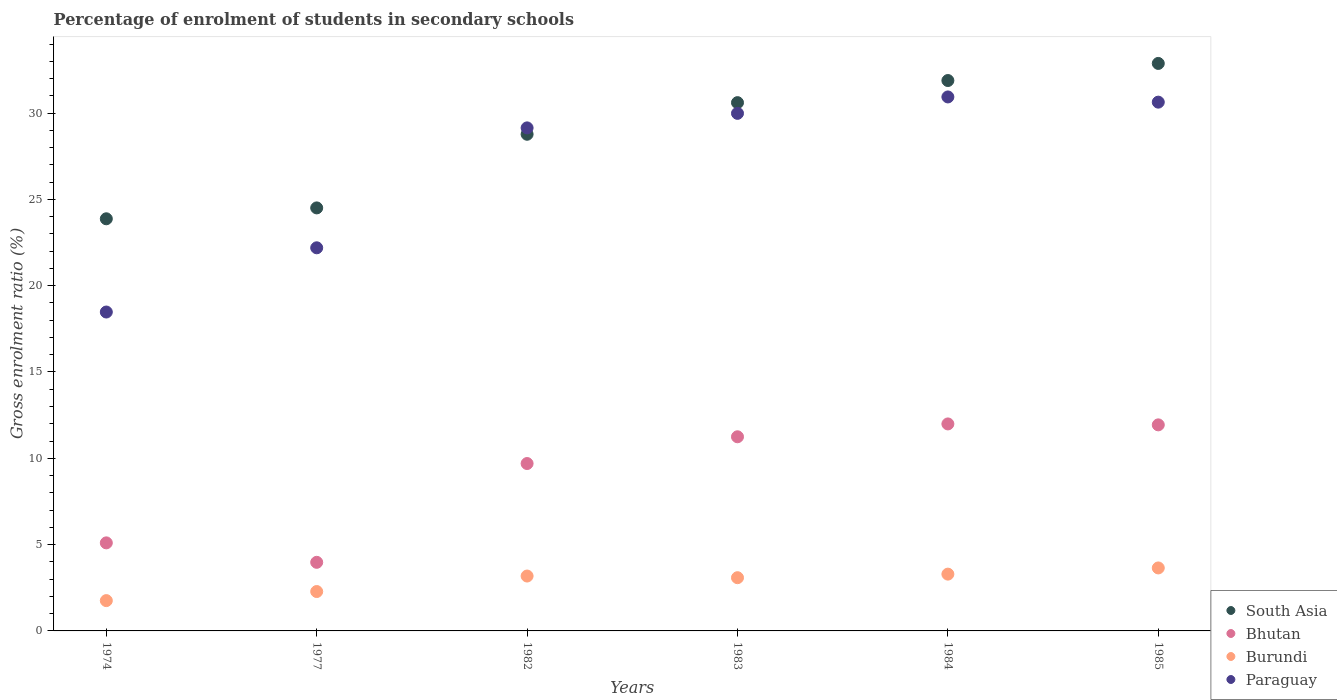What is the percentage of students enrolled in secondary schools in Bhutan in 1983?
Ensure brevity in your answer.  11.25. Across all years, what is the maximum percentage of students enrolled in secondary schools in Burundi?
Give a very brief answer. 3.65. Across all years, what is the minimum percentage of students enrolled in secondary schools in Paraguay?
Keep it short and to the point. 18.47. In which year was the percentage of students enrolled in secondary schools in Paraguay maximum?
Provide a short and direct response. 1984. In which year was the percentage of students enrolled in secondary schools in South Asia minimum?
Provide a short and direct response. 1974. What is the total percentage of students enrolled in secondary schools in Paraguay in the graph?
Ensure brevity in your answer.  161.36. What is the difference between the percentage of students enrolled in secondary schools in Paraguay in 1974 and that in 1984?
Ensure brevity in your answer.  -12.46. What is the difference between the percentage of students enrolled in secondary schools in Bhutan in 1984 and the percentage of students enrolled in secondary schools in South Asia in 1985?
Your response must be concise. -20.88. What is the average percentage of students enrolled in secondary schools in Bhutan per year?
Your answer should be compact. 8.99. In the year 1984, what is the difference between the percentage of students enrolled in secondary schools in Paraguay and percentage of students enrolled in secondary schools in Burundi?
Offer a terse response. 27.64. What is the ratio of the percentage of students enrolled in secondary schools in South Asia in 1977 to that in 1984?
Offer a very short reply. 0.77. Is the difference between the percentage of students enrolled in secondary schools in Paraguay in 1974 and 1985 greater than the difference between the percentage of students enrolled in secondary schools in Burundi in 1974 and 1985?
Ensure brevity in your answer.  No. What is the difference between the highest and the second highest percentage of students enrolled in secondary schools in Paraguay?
Your answer should be very brief. 0.3. What is the difference between the highest and the lowest percentage of students enrolled in secondary schools in Paraguay?
Offer a terse response. 12.46. In how many years, is the percentage of students enrolled in secondary schools in Paraguay greater than the average percentage of students enrolled in secondary schools in Paraguay taken over all years?
Offer a terse response. 4. Is it the case that in every year, the sum of the percentage of students enrolled in secondary schools in Bhutan and percentage of students enrolled in secondary schools in South Asia  is greater than the sum of percentage of students enrolled in secondary schools in Burundi and percentage of students enrolled in secondary schools in Paraguay?
Ensure brevity in your answer.  Yes. Does the percentage of students enrolled in secondary schools in Bhutan monotonically increase over the years?
Your answer should be very brief. No. Is the percentage of students enrolled in secondary schools in Burundi strictly greater than the percentage of students enrolled in secondary schools in Bhutan over the years?
Keep it short and to the point. No. Is the percentage of students enrolled in secondary schools in South Asia strictly less than the percentage of students enrolled in secondary schools in Bhutan over the years?
Provide a succinct answer. No. How many years are there in the graph?
Ensure brevity in your answer.  6. Does the graph contain grids?
Make the answer very short. No. Where does the legend appear in the graph?
Offer a terse response. Bottom right. What is the title of the graph?
Give a very brief answer. Percentage of enrolment of students in secondary schools. Does "Sao Tome and Principe" appear as one of the legend labels in the graph?
Provide a short and direct response. No. What is the label or title of the X-axis?
Keep it short and to the point. Years. What is the label or title of the Y-axis?
Give a very brief answer. Gross enrolment ratio (%). What is the Gross enrolment ratio (%) in South Asia in 1974?
Ensure brevity in your answer.  23.87. What is the Gross enrolment ratio (%) in Bhutan in 1974?
Keep it short and to the point. 5.1. What is the Gross enrolment ratio (%) in Burundi in 1974?
Your answer should be compact. 1.76. What is the Gross enrolment ratio (%) of Paraguay in 1974?
Keep it short and to the point. 18.47. What is the Gross enrolment ratio (%) of South Asia in 1977?
Provide a succinct answer. 24.51. What is the Gross enrolment ratio (%) of Bhutan in 1977?
Make the answer very short. 3.97. What is the Gross enrolment ratio (%) of Burundi in 1977?
Provide a succinct answer. 2.28. What is the Gross enrolment ratio (%) in Paraguay in 1977?
Provide a succinct answer. 22.19. What is the Gross enrolment ratio (%) of South Asia in 1982?
Offer a very short reply. 28.77. What is the Gross enrolment ratio (%) of Bhutan in 1982?
Keep it short and to the point. 9.7. What is the Gross enrolment ratio (%) of Burundi in 1982?
Offer a terse response. 3.18. What is the Gross enrolment ratio (%) of Paraguay in 1982?
Offer a terse response. 29.14. What is the Gross enrolment ratio (%) in South Asia in 1983?
Ensure brevity in your answer.  30.6. What is the Gross enrolment ratio (%) of Bhutan in 1983?
Offer a terse response. 11.25. What is the Gross enrolment ratio (%) of Burundi in 1983?
Provide a succinct answer. 3.08. What is the Gross enrolment ratio (%) in Paraguay in 1983?
Give a very brief answer. 29.98. What is the Gross enrolment ratio (%) of South Asia in 1984?
Your answer should be very brief. 31.88. What is the Gross enrolment ratio (%) in Bhutan in 1984?
Make the answer very short. 11.99. What is the Gross enrolment ratio (%) in Burundi in 1984?
Ensure brevity in your answer.  3.29. What is the Gross enrolment ratio (%) of Paraguay in 1984?
Offer a terse response. 30.93. What is the Gross enrolment ratio (%) of South Asia in 1985?
Offer a terse response. 32.87. What is the Gross enrolment ratio (%) in Bhutan in 1985?
Your answer should be compact. 11.94. What is the Gross enrolment ratio (%) in Burundi in 1985?
Give a very brief answer. 3.65. What is the Gross enrolment ratio (%) of Paraguay in 1985?
Offer a terse response. 30.63. Across all years, what is the maximum Gross enrolment ratio (%) of South Asia?
Offer a terse response. 32.87. Across all years, what is the maximum Gross enrolment ratio (%) in Bhutan?
Make the answer very short. 11.99. Across all years, what is the maximum Gross enrolment ratio (%) of Burundi?
Make the answer very short. 3.65. Across all years, what is the maximum Gross enrolment ratio (%) of Paraguay?
Offer a terse response. 30.93. Across all years, what is the minimum Gross enrolment ratio (%) of South Asia?
Your response must be concise. 23.87. Across all years, what is the minimum Gross enrolment ratio (%) of Bhutan?
Offer a terse response. 3.97. Across all years, what is the minimum Gross enrolment ratio (%) of Burundi?
Provide a succinct answer. 1.76. Across all years, what is the minimum Gross enrolment ratio (%) in Paraguay?
Make the answer very short. 18.47. What is the total Gross enrolment ratio (%) in South Asia in the graph?
Offer a very short reply. 172.51. What is the total Gross enrolment ratio (%) of Bhutan in the graph?
Ensure brevity in your answer.  53.95. What is the total Gross enrolment ratio (%) of Burundi in the graph?
Your response must be concise. 17.24. What is the total Gross enrolment ratio (%) in Paraguay in the graph?
Your response must be concise. 161.36. What is the difference between the Gross enrolment ratio (%) of South Asia in 1974 and that in 1977?
Your answer should be very brief. -0.63. What is the difference between the Gross enrolment ratio (%) of Bhutan in 1974 and that in 1977?
Provide a short and direct response. 1.13. What is the difference between the Gross enrolment ratio (%) of Burundi in 1974 and that in 1977?
Your response must be concise. -0.53. What is the difference between the Gross enrolment ratio (%) of Paraguay in 1974 and that in 1977?
Provide a short and direct response. -3.72. What is the difference between the Gross enrolment ratio (%) of South Asia in 1974 and that in 1982?
Provide a short and direct response. -4.9. What is the difference between the Gross enrolment ratio (%) of Bhutan in 1974 and that in 1982?
Your answer should be compact. -4.6. What is the difference between the Gross enrolment ratio (%) in Burundi in 1974 and that in 1982?
Your answer should be compact. -1.42. What is the difference between the Gross enrolment ratio (%) of Paraguay in 1974 and that in 1982?
Provide a short and direct response. -10.67. What is the difference between the Gross enrolment ratio (%) of South Asia in 1974 and that in 1983?
Provide a succinct answer. -6.73. What is the difference between the Gross enrolment ratio (%) in Bhutan in 1974 and that in 1983?
Ensure brevity in your answer.  -6.15. What is the difference between the Gross enrolment ratio (%) in Burundi in 1974 and that in 1983?
Your response must be concise. -1.33. What is the difference between the Gross enrolment ratio (%) of Paraguay in 1974 and that in 1983?
Offer a terse response. -11.51. What is the difference between the Gross enrolment ratio (%) in South Asia in 1974 and that in 1984?
Offer a terse response. -8.01. What is the difference between the Gross enrolment ratio (%) in Bhutan in 1974 and that in 1984?
Your answer should be compact. -6.89. What is the difference between the Gross enrolment ratio (%) in Burundi in 1974 and that in 1984?
Provide a short and direct response. -1.53. What is the difference between the Gross enrolment ratio (%) of Paraguay in 1974 and that in 1984?
Your response must be concise. -12.46. What is the difference between the Gross enrolment ratio (%) of South Asia in 1974 and that in 1985?
Offer a very short reply. -9. What is the difference between the Gross enrolment ratio (%) in Bhutan in 1974 and that in 1985?
Your answer should be very brief. -6.84. What is the difference between the Gross enrolment ratio (%) in Burundi in 1974 and that in 1985?
Your answer should be very brief. -1.89. What is the difference between the Gross enrolment ratio (%) of Paraguay in 1974 and that in 1985?
Offer a terse response. -12.16. What is the difference between the Gross enrolment ratio (%) in South Asia in 1977 and that in 1982?
Offer a terse response. -4.27. What is the difference between the Gross enrolment ratio (%) in Bhutan in 1977 and that in 1982?
Keep it short and to the point. -5.72. What is the difference between the Gross enrolment ratio (%) of Burundi in 1977 and that in 1982?
Your response must be concise. -0.9. What is the difference between the Gross enrolment ratio (%) of Paraguay in 1977 and that in 1982?
Ensure brevity in your answer.  -6.95. What is the difference between the Gross enrolment ratio (%) of South Asia in 1977 and that in 1983?
Offer a terse response. -6.1. What is the difference between the Gross enrolment ratio (%) of Bhutan in 1977 and that in 1983?
Ensure brevity in your answer.  -7.27. What is the difference between the Gross enrolment ratio (%) in Burundi in 1977 and that in 1983?
Your answer should be very brief. -0.8. What is the difference between the Gross enrolment ratio (%) of Paraguay in 1977 and that in 1983?
Give a very brief answer. -7.79. What is the difference between the Gross enrolment ratio (%) in South Asia in 1977 and that in 1984?
Make the answer very short. -7.38. What is the difference between the Gross enrolment ratio (%) of Bhutan in 1977 and that in 1984?
Offer a very short reply. -8.02. What is the difference between the Gross enrolment ratio (%) of Burundi in 1977 and that in 1984?
Provide a succinct answer. -1.01. What is the difference between the Gross enrolment ratio (%) of Paraguay in 1977 and that in 1984?
Keep it short and to the point. -8.74. What is the difference between the Gross enrolment ratio (%) of South Asia in 1977 and that in 1985?
Keep it short and to the point. -8.37. What is the difference between the Gross enrolment ratio (%) in Bhutan in 1977 and that in 1985?
Make the answer very short. -7.96. What is the difference between the Gross enrolment ratio (%) of Burundi in 1977 and that in 1985?
Your answer should be very brief. -1.37. What is the difference between the Gross enrolment ratio (%) in Paraguay in 1977 and that in 1985?
Provide a short and direct response. -8.44. What is the difference between the Gross enrolment ratio (%) of South Asia in 1982 and that in 1983?
Your answer should be very brief. -1.83. What is the difference between the Gross enrolment ratio (%) of Bhutan in 1982 and that in 1983?
Your response must be concise. -1.55. What is the difference between the Gross enrolment ratio (%) of Burundi in 1982 and that in 1983?
Give a very brief answer. 0.1. What is the difference between the Gross enrolment ratio (%) in Paraguay in 1982 and that in 1983?
Offer a very short reply. -0.84. What is the difference between the Gross enrolment ratio (%) in South Asia in 1982 and that in 1984?
Offer a terse response. -3.11. What is the difference between the Gross enrolment ratio (%) in Bhutan in 1982 and that in 1984?
Offer a terse response. -2.29. What is the difference between the Gross enrolment ratio (%) of Burundi in 1982 and that in 1984?
Your answer should be very brief. -0.11. What is the difference between the Gross enrolment ratio (%) in Paraguay in 1982 and that in 1984?
Offer a terse response. -1.79. What is the difference between the Gross enrolment ratio (%) in South Asia in 1982 and that in 1985?
Give a very brief answer. -4.1. What is the difference between the Gross enrolment ratio (%) of Bhutan in 1982 and that in 1985?
Keep it short and to the point. -2.24. What is the difference between the Gross enrolment ratio (%) of Burundi in 1982 and that in 1985?
Provide a succinct answer. -0.47. What is the difference between the Gross enrolment ratio (%) of Paraguay in 1982 and that in 1985?
Your answer should be compact. -1.49. What is the difference between the Gross enrolment ratio (%) of South Asia in 1983 and that in 1984?
Keep it short and to the point. -1.28. What is the difference between the Gross enrolment ratio (%) of Bhutan in 1983 and that in 1984?
Give a very brief answer. -0.74. What is the difference between the Gross enrolment ratio (%) in Burundi in 1983 and that in 1984?
Your answer should be compact. -0.21. What is the difference between the Gross enrolment ratio (%) of Paraguay in 1983 and that in 1984?
Keep it short and to the point. -0.95. What is the difference between the Gross enrolment ratio (%) in South Asia in 1983 and that in 1985?
Your response must be concise. -2.27. What is the difference between the Gross enrolment ratio (%) of Bhutan in 1983 and that in 1985?
Your response must be concise. -0.69. What is the difference between the Gross enrolment ratio (%) in Burundi in 1983 and that in 1985?
Your answer should be very brief. -0.57. What is the difference between the Gross enrolment ratio (%) of Paraguay in 1983 and that in 1985?
Offer a very short reply. -0.65. What is the difference between the Gross enrolment ratio (%) in South Asia in 1984 and that in 1985?
Ensure brevity in your answer.  -0.99. What is the difference between the Gross enrolment ratio (%) of Bhutan in 1984 and that in 1985?
Ensure brevity in your answer.  0.05. What is the difference between the Gross enrolment ratio (%) of Burundi in 1984 and that in 1985?
Your response must be concise. -0.36. What is the difference between the Gross enrolment ratio (%) in Paraguay in 1984 and that in 1985?
Provide a succinct answer. 0.3. What is the difference between the Gross enrolment ratio (%) of South Asia in 1974 and the Gross enrolment ratio (%) of Bhutan in 1977?
Ensure brevity in your answer.  19.9. What is the difference between the Gross enrolment ratio (%) in South Asia in 1974 and the Gross enrolment ratio (%) in Burundi in 1977?
Your answer should be compact. 21.59. What is the difference between the Gross enrolment ratio (%) of South Asia in 1974 and the Gross enrolment ratio (%) of Paraguay in 1977?
Offer a very short reply. 1.68. What is the difference between the Gross enrolment ratio (%) in Bhutan in 1974 and the Gross enrolment ratio (%) in Burundi in 1977?
Keep it short and to the point. 2.82. What is the difference between the Gross enrolment ratio (%) of Bhutan in 1974 and the Gross enrolment ratio (%) of Paraguay in 1977?
Offer a very short reply. -17.09. What is the difference between the Gross enrolment ratio (%) in Burundi in 1974 and the Gross enrolment ratio (%) in Paraguay in 1977?
Offer a terse response. -20.44. What is the difference between the Gross enrolment ratio (%) of South Asia in 1974 and the Gross enrolment ratio (%) of Bhutan in 1982?
Offer a terse response. 14.18. What is the difference between the Gross enrolment ratio (%) in South Asia in 1974 and the Gross enrolment ratio (%) in Burundi in 1982?
Ensure brevity in your answer.  20.7. What is the difference between the Gross enrolment ratio (%) of South Asia in 1974 and the Gross enrolment ratio (%) of Paraguay in 1982?
Your response must be concise. -5.27. What is the difference between the Gross enrolment ratio (%) of Bhutan in 1974 and the Gross enrolment ratio (%) of Burundi in 1982?
Provide a succinct answer. 1.92. What is the difference between the Gross enrolment ratio (%) in Bhutan in 1974 and the Gross enrolment ratio (%) in Paraguay in 1982?
Offer a terse response. -24.04. What is the difference between the Gross enrolment ratio (%) in Burundi in 1974 and the Gross enrolment ratio (%) in Paraguay in 1982?
Ensure brevity in your answer.  -27.38. What is the difference between the Gross enrolment ratio (%) in South Asia in 1974 and the Gross enrolment ratio (%) in Bhutan in 1983?
Your response must be concise. 12.63. What is the difference between the Gross enrolment ratio (%) of South Asia in 1974 and the Gross enrolment ratio (%) of Burundi in 1983?
Your response must be concise. 20.79. What is the difference between the Gross enrolment ratio (%) in South Asia in 1974 and the Gross enrolment ratio (%) in Paraguay in 1983?
Your response must be concise. -6.11. What is the difference between the Gross enrolment ratio (%) of Bhutan in 1974 and the Gross enrolment ratio (%) of Burundi in 1983?
Offer a very short reply. 2.02. What is the difference between the Gross enrolment ratio (%) in Bhutan in 1974 and the Gross enrolment ratio (%) in Paraguay in 1983?
Your answer should be very brief. -24.88. What is the difference between the Gross enrolment ratio (%) of Burundi in 1974 and the Gross enrolment ratio (%) of Paraguay in 1983?
Provide a short and direct response. -28.23. What is the difference between the Gross enrolment ratio (%) of South Asia in 1974 and the Gross enrolment ratio (%) of Bhutan in 1984?
Your answer should be compact. 11.88. What is the difference between the Gross enrolment ratio (%) in South Asia in 1974 and the Gross enrolment ratio (%) in Burundi in 1984?
Offer a very short reply. 20.58. What is the difference between the Gross enrolment ratio (%) of South Asia in 1974 and the Gross enrolment ratio (%) of Paraguay in 1984?
Offer a very short reply. -7.06. What is the difference between the Gross enrolment ratio (%) in Bhutan in 1974 and the Gross enrolment ratio (%) in Burundi in 1984?
Ensure brevity in your answer.  1.81. What is the difference between the Gross enrolment ratio (%) of Bhutan in 1974 and the Gross enrolment ratio (%) of Paraguay in 1984?
Give a very brief answer. -25.83. What is the difference between the Gross enrolment ratio (%) in Burundi in 1974 and the Gross enrolment ratio (%) in Paraguay in 1984?
Offer a terse response. -29.18. What is the difference between the Gross enrolment ratio (%) of South Asia in 1974 and the Gross enrolment ratio (%) of Bhutan in 1985?
Offer a very short reply. 11.94. What is the difference between the Gross enrolment ratio (%) of South Asia in 1974 and the Gross enrolment ratio (%) of Burundi in 1985?
Ensure brevity in your answer.  20.23. What is the difference between the Gross enrolment ratio (%) in South Asia in 1974 and the Gross enrolment ratio (%) in Paraguay in 1985?
Provide a short and direct response. -6.76. What is the difference between the Gross enrolment ratio (%) in Bhutan in 1974 and the Gross enrolment ratio (%) in Burundi in 1985?
Give a very brief answer. 1.45. What is the difference between the Gross enrolment ratio (%) of Bhutan in 1974 and the Gross enrolment ratio (%) of Paraguay in 1985?
Provide a succinct answer. -25.53. What is the difference between the Gross enrolment ratio (%) of Burundi in 1974 and the Gross enrolment ratio (%) of Paraguay in 1985?
Provide a short and direct response. -28.88. What is the difference between the Gross enrolment ratio (%) in South Asia in 1977 and the Gross enrolment ratio (%) in Bhutan in 1982?
Keep it short and to the point. 14.81. What is the difference between the Gross enrolment ratio (%) of South Asia in 1977 and the Gross enrolment ratio (%) of Burundi in 1982?
Ensure brevity in your answer.  21.33. What is the difference between the Gross enrolment ratio (%) of South Asia in 1977 and the Gross enrolment ratio (%) of Paraguay in 1982?
Ensure brevity in your answer.  -4.64. What is the difference between the Gross enrolment ratio (%) of Bhutan in 1977 and the Gross enrolment ratio (%) of Burundi in 1982?
Make the answer very short. 0.79. What is the difference between the Gross enrolment ratio (%) of Bhutan in 1977 and the Gross enrolment ratio (%) of Paraguay in 1982?
Make the answer very short. -25.17. What is the difference between the Gross enrolment ratio (%) of Burundi in 1977 and the Gross enrolment ratio (%) of Paraguay in 1982?
Your answer should be very brief. -26.86. What is the difference between the Gross enrolment ratio (%) of South Asia in 1977 and the Gross enrolment ratio (%) of Bhutan in 1983?
Offer a terse response. 13.26. What is the difference between the Gross enrolment ratio (%) of South Asia in 1977 and the Gross enrolment ratio (%) of Burundi in 1983?
Ensure brevity in your answer.  21.42. What is the difference between the Gross enrolment ratio (%) in South Asia in 1977 and the Gross enrolment ratio (%) in Paraguay in 1983?
Provide a succinct answer. -5.48. What is the difference between the Gross enrolment ratio (%) of Bhutan in 1977 and the Gross enrolment ratio (%) of Burundi in 1983?
Provide a short and direct response. 0.89. What is the difference between the Gross enrolment ratio (%) of Bhutan in 1977 and the Gross enrolment ratio (%) of Paraguay in 1983?
Provide a succinct answer. -26.01. What is the difference between the Gross enrolment ratio (%) in Burundi in 1977 and the Gross enrolment ratio (%) in Paraguay in 1983?
Ensure brevity in your answer.  -27.7. What is the difference between the Gross enrolment ratio (%) of South Asia in 1977 and the Gross enrolment ratio (%) of Bhutan in 1984?
Keep it short and to the point. 12.51. What is the difference between the Gross enrolment ratio (%) of South Asia in 1977 and the Gross enrolment ratio (%) of Burundi in 1984?
Provide a short and direct response. 21.22. What is the difference between the Gross enrolment ratio (%) in South Asia in 1977 and the Gross enrolment ratio (%) in Paraguay in 1984?
Provide a succinct answer. -6.43. What is the difference between the Gross enrolment ratio (%) of Bhutan in 1977 and the Gross enrolment ratio (%) of Burundi in 1984?
Your answer should be compact. 0.68. What is the difference between the Gross enrolment ratio (%) of Bhutan in 1977 and the Gross enrolment ratio (%) of Paraguay in 1984?
Your response must be concise. -26.96. What is the difference between the Gross enrolment ratio (%) of Burundi in 1977 and the Gross enrolment ratio (%) of Paraguay in 1984?
Offer a terse response. -28.65. What is the difference between the Gross enrolment ratio (%) in South Asia in 1977 and the Gross enrolment ratio (%) in Bhutan in 1985?
Your response must be concise. 12.57. What is the difference between the Gross enrolment ratio (%) in South Asia in 1977 and the Gross enrolment ratio (%) in Burundi in 1985?
Make the answer very short. 20.86. What is the difference between the Gross enrolment ratio (%) of South Asia in 1977 and the Gross enrolment ratio (%) of Paraguay in 1985?
Make the answer very short. -6.13. What is the difference between the Gross enrolment ratio (%) in Bhutan in 1977 and the Gross enrolment ratio (%) in Burundi in 1985?
Provide a short and direct response. 0.33. What is the difference between the Gross enrolment ratio (%) in Bhutan in 1977 and the Gross enrolment ratio (%) in Paraguay in 1985?
Give a very brief answer. -26.66. What is the difference between the Gross enrolment ratio (%) in Burundi in 1977 and the Gross enrolment ratio (%) in Paraguay in 1985?
Ensure brevity in your answer.  -28.35. What is the difference between the Gross enrolment ratio (%) of South Asia in 1982 and the Gross enrolment ratio (%) of Bhutan in 1983?
Give a very brief answer. 17.53. What is the difference between the Gross enrolment ratio (%) in South Asia in 1982 and the Gross enrolment ratio (%) in Burundi in 1983?
Offer a terse response. 25.69. What is the difference between the Gross enrolment ratio (%) in South Asia in 1982 and the Gross enrolment ratio (%) in Paraguay in 1983?
Keep it short and to the point. -1.21. What is the difference between the Gross enrolment ratio (%) of Bhutan in 1982 and the Gross enrolment ratio (%) of Burundi in 1983?
Your answer should be very brief. 6.61. What is the difference between the Gross enrolment ratio (%) in Bhutan in 1982 and the Gross enrolment ratio (%) in Paraguay in 1983?
Provide a succinct answer. -20.29. What is the difference between the Gross enrolment ratio (%) of Burundi in 1982 and the Gross enrolment ratio (%) of Paraguay in 1983?
Keep it short and to the point. -26.8. What is the difference between the Gross enrolment ratio (%) in South Asia in 1982 and the Gross enrolment ratio (%) in Bhutan in 1984?
Give a very brief answer. 16.78. What is the difference between the Gross enrolment ratio (%) in South Asia in 1982 and the Gross enrolment ratio (%) in Burundi in 1984?
Offer a very short reply. 25.48. What is the difference between the Gross enrolment ratio (%) in South Asia in 1982 and the Gross enrolment ratio (%) in Paraguay in 1984?
Keep it short and to the point. -2.16. What is the difference between the Gross enrolment ratio (%) of Bhutan in 1982 and the Gross enrolment ratio (%) of Burundi in 1984?
Provide a succinct answer. 6.41. What is the difference between the Gross enrolment ratio (%) of Bhutan in 1982 and the Gross enrolment ratio (%) of Paraguay in 1984?
Offer a terse response. -21.24. What is the difference between the Gross enrolment ratio (%) in Burundi in 1982 and the Gross enrolment ratio (%) in Paraguay in 1984?
Make the answer very short. -27.75. What is the difference between the Gross enrolment ratio (%) in South Asia in 1982 and the Gross enrolment ratio (%) in Bhutan in 1985?
Provide a short and direct response. 16.83. What is the difference between the Gross enrolment ratio (%) in South Asia in 1982 and the Gross enrolment ratio (%) in Burundi in 1985?
Your answer should be compact. 25.12. What is the difference between the Gross enrolment ratio (%) of South Asia in 1982 and the Gross enrolment ratio (%) of Paraguay in 1985?
Provide a short and direct response. -1.86. What is the difference between the Gross enrolment ratio (%) of Bhutan in 1982 and the Gross enrolment ratio (%) of Burundi in 1985?
Provide a short and direct response. 6.05. What is the difference between the Gross enrolment ratio (%) of Bhutan in 1982 and the Gross enrolment ratio (%) of Paraguay in 1985?
Provide a short and direct response. -20.93. What is the difference between the Gross enrolment ratio (%) in Burundi in 1982 and the Gross enrolment ratio (%) in Paraguay in 1985?
Your response must be concise. -27.45. What is the difference between the Gross enrolment ratio (%) of South Asia in 1983 and the Gross enrolment ratio (%) of Bhutan in 1984?
Ensure brevity in your answer.  18.61. What is the difference between the Gross enrolment ratio (%) of South Asia in 1983 and the Gross enrolment ratio (%) of Burundi in 1984?
Offer a terse response. 27.31. What is the difference between the Gross enrolment ratio (%) of South Asia in 1983 and the Gross enrolment ratio (%) of Paraguay in 1984?
Provide a short and direct response. -0.33. What is the difference between the Gross enrolment ratio (%) of Bhutan in 1983 and the Gross enrolment ratio (%) of Burundi in 1984?
Provide a succinct answer. 7.96. What is the difference between the Gross enrolment ratio (%) of Bhutan in 1983 and the Gross enrolment ratio (%) of Paraguay in 1984?
Provide a short and direct response. -19.69. What is the difference between the Gross enrolment ratio (%) in Burundi in 1983 and the Gross enrolment ratio (%) in Paraguay in 1984?
Your response must be concise. -27.85. What is the difference between the Gross enrolment ratio (%) in South Asia in 1983 and the Gross enrolment ratio (%) in Bhutan in 1985?
Give a very brief answer. 18.67. What is the difference between the Gross enrolment ratio (%) of South Asia in 1983 and the Gross enrolment ratio (%) of Burundi in 1985?
Provide a short and direct response. 26.95. What is the difference between the Gross enrolment ratio (%) of South Asia in 1983 and the Gross enrolment ratio (%) of Paraguay in 1985?
Your answer should be compact. -0.03. What is the difference between the Gross enrolment ratio (%) in Bhutan in 1983 and the Gross enrolment ratio (%) in Burundi in 1985?
Your answer should be compact. 7.6. What is the difference between the Gross enrolment ratio (%) in Bhutan in 1983 and the Gross enrolment ratio (%) in Paraguay in 1985?
Offer a terse response. -19.39. What is the difference between the Gross enrolment ratio (%) in Burundi in 1983 and the Gross enrolment ratio (%) in Paraguay in 1985?
Provide a succinct answer. -27.55. What is the difference between the Gross enrolment ratio (%) of South Asia in 1984 and the Gross enrolment ratio (%) of Bhutan in 1985?
Your answer should be very brief. 19.95. What is the difference between the Gross enrolment ratio (%) in South Asia in 1984 and the Gross enrolment ratio (%) in Burundi in 1985?
Your response must be concise. 28.24. What is the difference between the Gross enrolment ratio (%) in South Asia in 1984 and the Gross enrolment ratio (%) in Paraguay in 1985?
Give a very brief answer. 1.25. What is the difference between the Gross enrolment ratio (%) in Bhutan in 1984 and the Gross enrolment ratio (%) in Burundi in 1985?
Offer a terse response. 8.34. What is the difference between the Gross enrolment ratio (%) in Bhutan in 1984 and the Gross enrolment ratio (%) in Paraguay in 1985?
Your answer should be very brief. -18.64. What is the difference between the Gross enrolment ratio (%) of Burundi in 1984 and the Gross enrolment ratio (%) of Paraguay in 1985?
Your answer should be very brief. -27.34. What is the average Gross enrolment ratio (%) of South Asia per year?
Provide a short and direct response. 28.75. What is the average Gross enrolment ratio (%) of Bhutan per year?
Provide a short and direct response. 8.99. What is the average Gross enrolment ratio (%) in Burundi per year?
Provide a short and direct response. 2.87. What is the average Gross enrolment ratio (%) in Paraguay per year?
Make the answer very short. 26.89. In the year 1974, what is the difference between the Gross enrolment ratio (%) of South Asia and Gross enrolment ratio (%) of Bhutan?
Offer a very short reply. 18.77. In the year 1974, what is the difference between the Gross enrolment ratio (%) of South Asia and Gross enrolment ratio (%) of Burundi?
Your response must be concise. 22.12. In the year 1974, what is the difference between the Gross enrolment ratio (%) of South Asia and Gross enrolment ratio (%) of Paraguay?
Keep it short and to the point. 5.4. In the year 1974, what is the difference between the Gross enrolment ratio (%) of Bhutan and Gross enrolment ratio (%) of Burundi?
Give a very brief answer. 3.34. In the year 1974, what is the difference between the Gross enrolment ratio (%) of Bhutan and Gross enrolment ratio (%) of Paraguay?
Give a very brief answer. -13.37. In the year 1974, what is the difference between the Gross enrolment ratio (%) in Burundi and Gross enrolment ratio (%) in Paraguay?
Keep it short and to the point. -16.72. In the year 1977, what is the difference between the Gross enrolment ratio (%) of South Asia and Gross enrolment ratio (%) of Bhutan?
Provide a short and direct response. 20.53. In the year 1977, what is the difference between the Gross enrolment ratio (%) in South Asia and Gross enrolment ratio (%) in Burundi?
Your answer should be very brief. 22.22. In the year 1977, what is the difference between the Gross enrolment ratio (%) of South Asia and Gross enrolment ratio (%) of Paraguay?
Provide a succinct answer. 2.31. In the year 1977, what is the difference between the Gross enrolment ratio (%) of Bhutan and Gross enrolment ratio (%) of Burundi?
Give a very brief answer. 1.69. In the year 1977, what is the difference between the Gross enrolment ratio (%) of Bhutan and Gross enrolment ratio (%) of Paraguay?
Your response must be concise. -18.22. In the year 1977, what is the difference between the Gross enrolment ratio (%) of Burundi and Gross enrolment ratio (%) of Paraguay?
Provide a succinct answer. -19.91. In the year 1982, what is the difference between the Gross enrolment ratio (%) in South Asia and Gross enrolment ratio (%) in Bhutan?
Offer a terse response. 19.07. In the year 1982, what is the difference between the Gross enrolment ratio (%) in South Asia and Gross enrolment ratio (%) in Burundi?
Give a very brief answer. 25.59. In the year 1982, what is the difference between the Gross enrolment ratio (%) in South Asia and Gross enrolment ratio (%) in Paraguay?
Your response must be concise. -0.37. In the year 1982, what is the difference between the Gross enrolment ratio (%) in Bhutan and Gross enrolment ratio (%) in Burundi?
Your answer should be compact. 6.52. In the year 1982, what is the difference between the Gross enrolment ratio (%) of Bhutan and Gross enrolment ratio (%) of Paraguay?
Ensure brevity in your answer.  -19.44. In the year 1982, what is the difference between the Gross enrolment ratio (%) of Burundi and Gross enrolment ratio (%) of Paraguay?
Your answer should be compact. -25.96. In the year 1983, what is the difference between the Gross enrolment ratio (%) of South Asia and Gross enrolment ratio (%) of Bhutan?
Offer a very short reply. 19.36. In the year 1983, what is the difference between the Gross enrolment ratio (%) in South Asia and Gross enrolment ratio (%) in Burundi?
Provide a short and direct response. 27.52. In the year 1983, what is the difference between the Gross enrolment ratio (%) in South Asia and Gross enrolment ratio (%) in Paraguay?
Make the answer very short. 0.62. In the year 1983, what is the difference between the Gross enrolment ratio (%) in Bhutan and Gross enrolment ratio (%) in Burundi?
Keep it short and to the point. 8.16. In the year 1983, what is the difference between the Gross enrolment ratio (%) in Bhutan and Gross enrolment ratio (%) in Paraguay?
Your answer should be very brief. -18.74. In the year 1983, what is the difference between the Gross enrolment ratio (%) of Burundi and Gross enrolment ratio (%) of Paraguay?
Your response must be concise. -26.9. In the year 1984, what is the difference between the Gross enrolment ratio (%) of South Asia and Gross enrolment ratio (%) of Bhutan?
Provide a succinct answer. 19.89. In the year 1984, what is the difference between the Gross enrolment ratio (%) of South Asia and Gross enrolment ratio (%) of Burundi?
Make the answer very short. 28.59. In the year 1984, what is the difference between the Gross enrolment ratio (%) of South Asia and Gross enrolment ratio (%) of Paraguay?
Your response must be concise. 0.95. In the year 1984, what is the difference between the Gross enrolment ratio (%) of Bhutan and Gross enrolment ratio (%) of Burundi?
Your answer should be very brief. 8.7. In the year 1984, what is the difference between the Gross enrolment ratio (%) in Bhutan and Gross enrolment ratio (%) in Paraguay?
Provide a succinct answer. -18.94. In the year 1984, what is the difference between the Gross enrolment ratio (%) of Burundi and Gross enrolment ratio (%) of Paraguay?
Give a very brief answer. -27.64. In the year 1985, what is the difference between the Gross enrolment ratio (%) of South Asia and Gross enrolment ratio (%) of Bhutan?
Offer a very short reply. 20.94. In the year 1985, what is the difference between the Gross enrolment ratio (%) of South Asia and Gross enrolment ratio (%) of Burundi?
Your answer should be compact. 29.23. In the year 1985, what is the difference between the Gross enrolment ratio (%) of South Asia and Gross enrolment ratio (%) of Paraguay?
Ensure brevity in your answer.  2.24. In the year 1985, what is the difference between the Gross enrolment ratio (%) in Bhutan and Gross enrolment ratio (%) in Burundi?
Your answer should be compact. 8.29. In the year 1985, what is the difference between the Gross enrolment ratio (%) of Bhutan and Gross enrolment ratio (%) of Paraguay?
Ensure brevity in your answer.  -18.7. In the year 1985, what is the difference between the Gross enrolment ratio (%) in Burundi and Gross enrolment ratio (%) in Paraguay?
Ensure brevity in your answer.  -26.98. What is the ratio of the Gross enrolment ratio (%) of South Asia in 1974 to that in 1977?
Your response must be concise. 0.97. What is the ratio of the Gross enrolment ratio (%) in Bhutan in 1974 to that in 1977?
Give a very brief answer. 1.28. What is the ratio of the Gross enrolment ratio (%) of Burundi in 1974 to that in 1977?
Your response must be concise. 0.77. What is the ratio of the Gross enrolment ratio (%) in Paraguay in 1974 to that in 1977?
Offer a terse response. 0.83. What is the ratio of the Gross enrolment ratio (%) in South Asia in 1974 to that in 1982?
Ensure brevity in your answer.  0.83. What is the ratio of the Gross enrolment ratio (%) in Bhutan in 1974 to that in 1982?
Provide a short and direct response. 0.53. What is the ratio of the Gross enrolment ratio (%) in Burundi in 1974 to that in 1982?
Your answer should be compact. 0.55. What is the ratio of the Gross enrolment ratio (%) of Paraguay in 1974 to that in 1982?
Your answer should be very brief. 0.63. What is the ratio of the Gross enrolment ratio (%) in South Asia in 1974 to that in 1983?
Provide a short and direct response. 0.78. What is the ratio of the Gross enrolment ratio (%) of Bhutan in 1974 to that in 1983?
Your answer should be very brief. 0.45. What is the ratio of the Gross enrolment ratio (%) of Burundi in 1974 to that in 1983?
Keep it short and to the point. 0.57. What is the ratio of the Gross enrolment ratio (%) of Paraguay in 1974 to that in 1983?
Ensure brevity in your answer.  0.62. What is the ratio of the Gross enrolment ratio (%) in South Asia in 1974 to that in 1984?
Your answer should be compact. 0.75. What is the ratio of the Gross enrolment ratio (%) in Bhutan in 1974 to that in 1984?
Make the answer very short. 0.43. What is the ratio of the Gross enrolment ratio (%) of Burundi in 1974 to that in 1984?
Provide a short and direct response. 0.53. What is the ratio of the Gross enrolment ratio (%) in Paraguay in 1974 to that in 1984?
Your answer should be compact. 0.6. What is the ratio of the Gross enrolment ratio (%) in South Asia in 1974 to that in 1985?
Provide a succinct answer. 0.73. What is the ratio of the Gross enrolment ratio (%) in Bhutan in 1974 to that in 1985?
Ensure brevity in your answer.  0.43. What is the ratio of the Gross enrolment ratio (%) in Burundi in 1974 to that in 1985?
Ensure brevity in your answer.  0.48. What is the ratio of the Gross enrolment ratio (%) in Paraguay in 1974 to that in 1985?
Offer a very short reply. 0.6. What is the ratio of the Gross enrolment ratio (%) of South Asia in 1977 to that in 1982?
Your response must be concise. 0.85. What is the ratio of the Gross enrolment ratio (%) in Bhutan in 1977 to that in 1982?
Ensure brevity in your answer.  0.41. What is the ratio of the Gross enrolment ratio (%) of Burundi in 1977 to that in 1982?
Give a very brief answer. 0.72. What is the ratio of the Gross enrolment ratio (%) of Paraguay in 1977 to that in 1982?
Keep it short and to the point. 0.76. What is the ratio of the Gross enrolment ratio (%) in South Asia in 1977 to that in 1983?
Your response must be concise. 0.8. What is the ratio of the Gross enrolment ratio (%) of Bhutan in 1977 to that in 1983?
Keep it short and to the point. 0.35. What is the ratio of the Gross enrolment ratio (%) of Burundi in 1977 to that in 1983?
Give a very brief answer. 0.74. What is the ratio of the Gross enrolment ratio (%) in Paraguay in 1977 to that in 1983?
Keep it short and to the point. 0.74. What is the ratio of the Gross enrolment ratio (%) in South Asia in 1977 to that in 1984?
Make the answer very short. 0.77. What is the ratio of the Gross enrolment ratio (%) in Bhutan in 1977 to that in 1984?
Provide a short and direct response. 0.33. What is the ratio of the Gross enrolment ratio (%) of Burundi in 1977 to that in 1984?
Offer a terse response. 0.69. What is the ratio of the Gross enrolment ratio (%) of Paraguay in 1977 to that in 1984?
Your answer should be compact. 0.72. What is the ratio of the Gross enrolment ratio (%) of South Asia in 1977 to that in 1985?
Give a very brief answer. 0.75. What is the ratio of the Gross enrolment ratio (%) in Bhutan in 1977 to that in 1985?
Provide a short and direct response. 0.33. What is the ratio of the Gross enrolment ratio (%) in Burundi in 1977 to that in 1985?
Your answer should be very brief. 0.63. What is the ratio of the Gross enrolment ratio (%) of Paraguay in 1977 to that in 1985?
Offer a very short reply. 0.72. What is the ratio of the Gross enrolment ratio (%) of South Asia in 1982 to that in 1983?
Your response must be concise. 0.94. What is the ratio of the Gross enrolment ratio (%) of Bhutan in 1982 to that in 1983?
Provide a short and direct response. 0.86. What is the ratio of the Gross enrolment ratio (%) of Burundi in 1982 to that in 1983?
Keep it short and to the point. 1.03. What is the ratio of the Gross enrolment ratio (%) in Paraguay in 1982 to that in 1983?
Offer a terse response. 0.97. What is the ratio of the Gross enrolment ratio (%) in South Asia in 1982 to that in 1984?
Provide a short and direct response. 0.9. What is the ratio of the Gross enrolment ratio (%) of Bhutan in 1982 to that in 1984?
Give a very brief answer. 0.81. What is the ratio of the Gross enrolment ratio (%) of Burundi in 1982 to that in 1984?
Your response must be concise. 0.97. What is the ratio of the Gross enrolment ratio (%) of Paraguay in 1982 to that in 1984?
Your answer should be compact. 0.94. What is the ratio of the Gross enrolment ratio (%) in South Asia in 1982 to that in 1985?
Give a very brief answer. 0.88. What is the ratio of the Gross enrolment ratio (%) in Bhutan in 1982 to that in 1985?
Ensure brevity in your answer.  0.81. What is the ratio of the Gross enrolment ratio (%) of Burundi in 1982 to that in 1985?
Make the answer very short. 0.87. What is the ratio of the Gross enrolment ratio (%) of Paraguay in 1982 to that in 1985?
Your response must be concise. 0.95. What is the ratio of the Gross enrolment ratio (%) in South Asia in 1983 to that in 1984?
Your answer should be very brief. 0.96. What is the ratio of the Gross enrolment ratio (%) in Bhutan in 1983 to that in 1984?
Ensure brevity in your answer.  0.94. What is the ratio of the Gross enrolment ratio (%) of Burundi in 1983 to that in 1984?
Offer a very short reply. 0.94. What is the ratio of the Gross enrolment ratio (%) of Paraguay in 1983 to that in 1984?
Keep it short and to the point. 0.97. What is the ratio of the Gross enrolment ratio (%) in South Asia in 1983 to that in 1985?
Your answer should be very brief. 0.93. What is the ratio of the Gross enrolment ratio (%) of Bhutan in 1983 to that in 1985?
Offer a very short reply. 0.94. What is the ratio of the Gross enrolment ratio (%) of Burundi in 1983 to that in 1985?
Ensure brevity in your answer.  0.84. What is the ratio of the Gross enrolment ratio (%) in Paraguay in 1983 to that in 1985?
Your response must be concise. 0.98. What is the ratio of the Gross enrolment ratio (%) in South Asia in 1984 to that in 1985?
Your answer should be very brief. 0.97. What is the ratio of the Gross enrolment ratio (%) of Bhutan in 1984 to that in 1985?
Ensure brevity in your answer.  1. What is the ratio of the Gross enrolment ratio (%) in Burundi in 1984 to that in 1985?
Your answer should be very brief. 0.9. What is the ratio of the Gross enrolment ratio (%) of Paraguay in 1984 to that in 1985?
Ensure brevity in your answer.  1.01. What is the difference between the highest and the second highest Gross enrolment ratio (%) in Bhutan?
Give a very brief answer. 0.05. What is the difference between the highest and the second highest Gross enrolment ratio (%) in Burundi?
Provide a short and direct response. 0.36. What is the difference between the highest and the second highest Gross enrolment ratio (%) of Paraguay?
Ensure brevity in your answer.  0.3. What is the difference between the highest and the lowest Gross enrolment ratio (%) in South Asia?
Your answer should be compact. 9. What is the difference between the highest and the lowest Gross enrolment ratio (%) in Bhutan?
Offer a very short reply. 8.02. What is the difference between the highest and the lowest Gross enrolment ratio (%) of Burundi?
Your answer should be compact. 1.89. What is the difference between the highest and the lowest Gross enrolment ratio (%) in Paraguay?
Your answer should be compact. 12.46. 